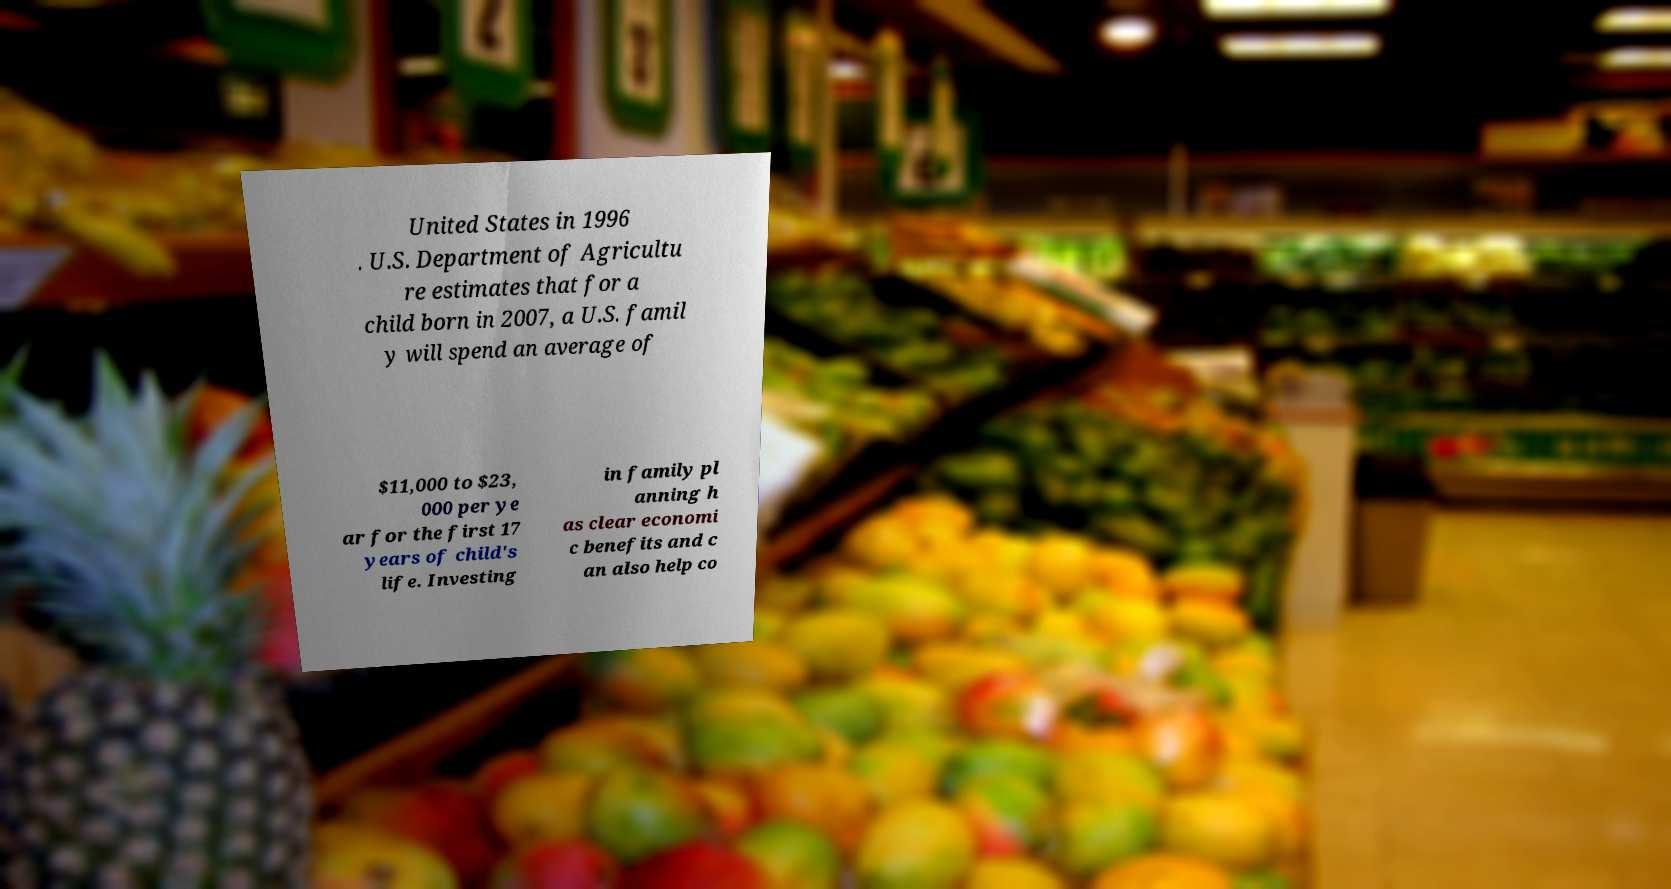Could you extract and type out the text from this image? United States in 1996 . U.S. Department of Agricultu re estimates that for a child born in 2007, a U.S. famil y will spend an average of $11,000 to $23, 000 per ye ar for the first 17 years of child's life. Investing in family pl anning h as clear economi c benefits and c an also help co 